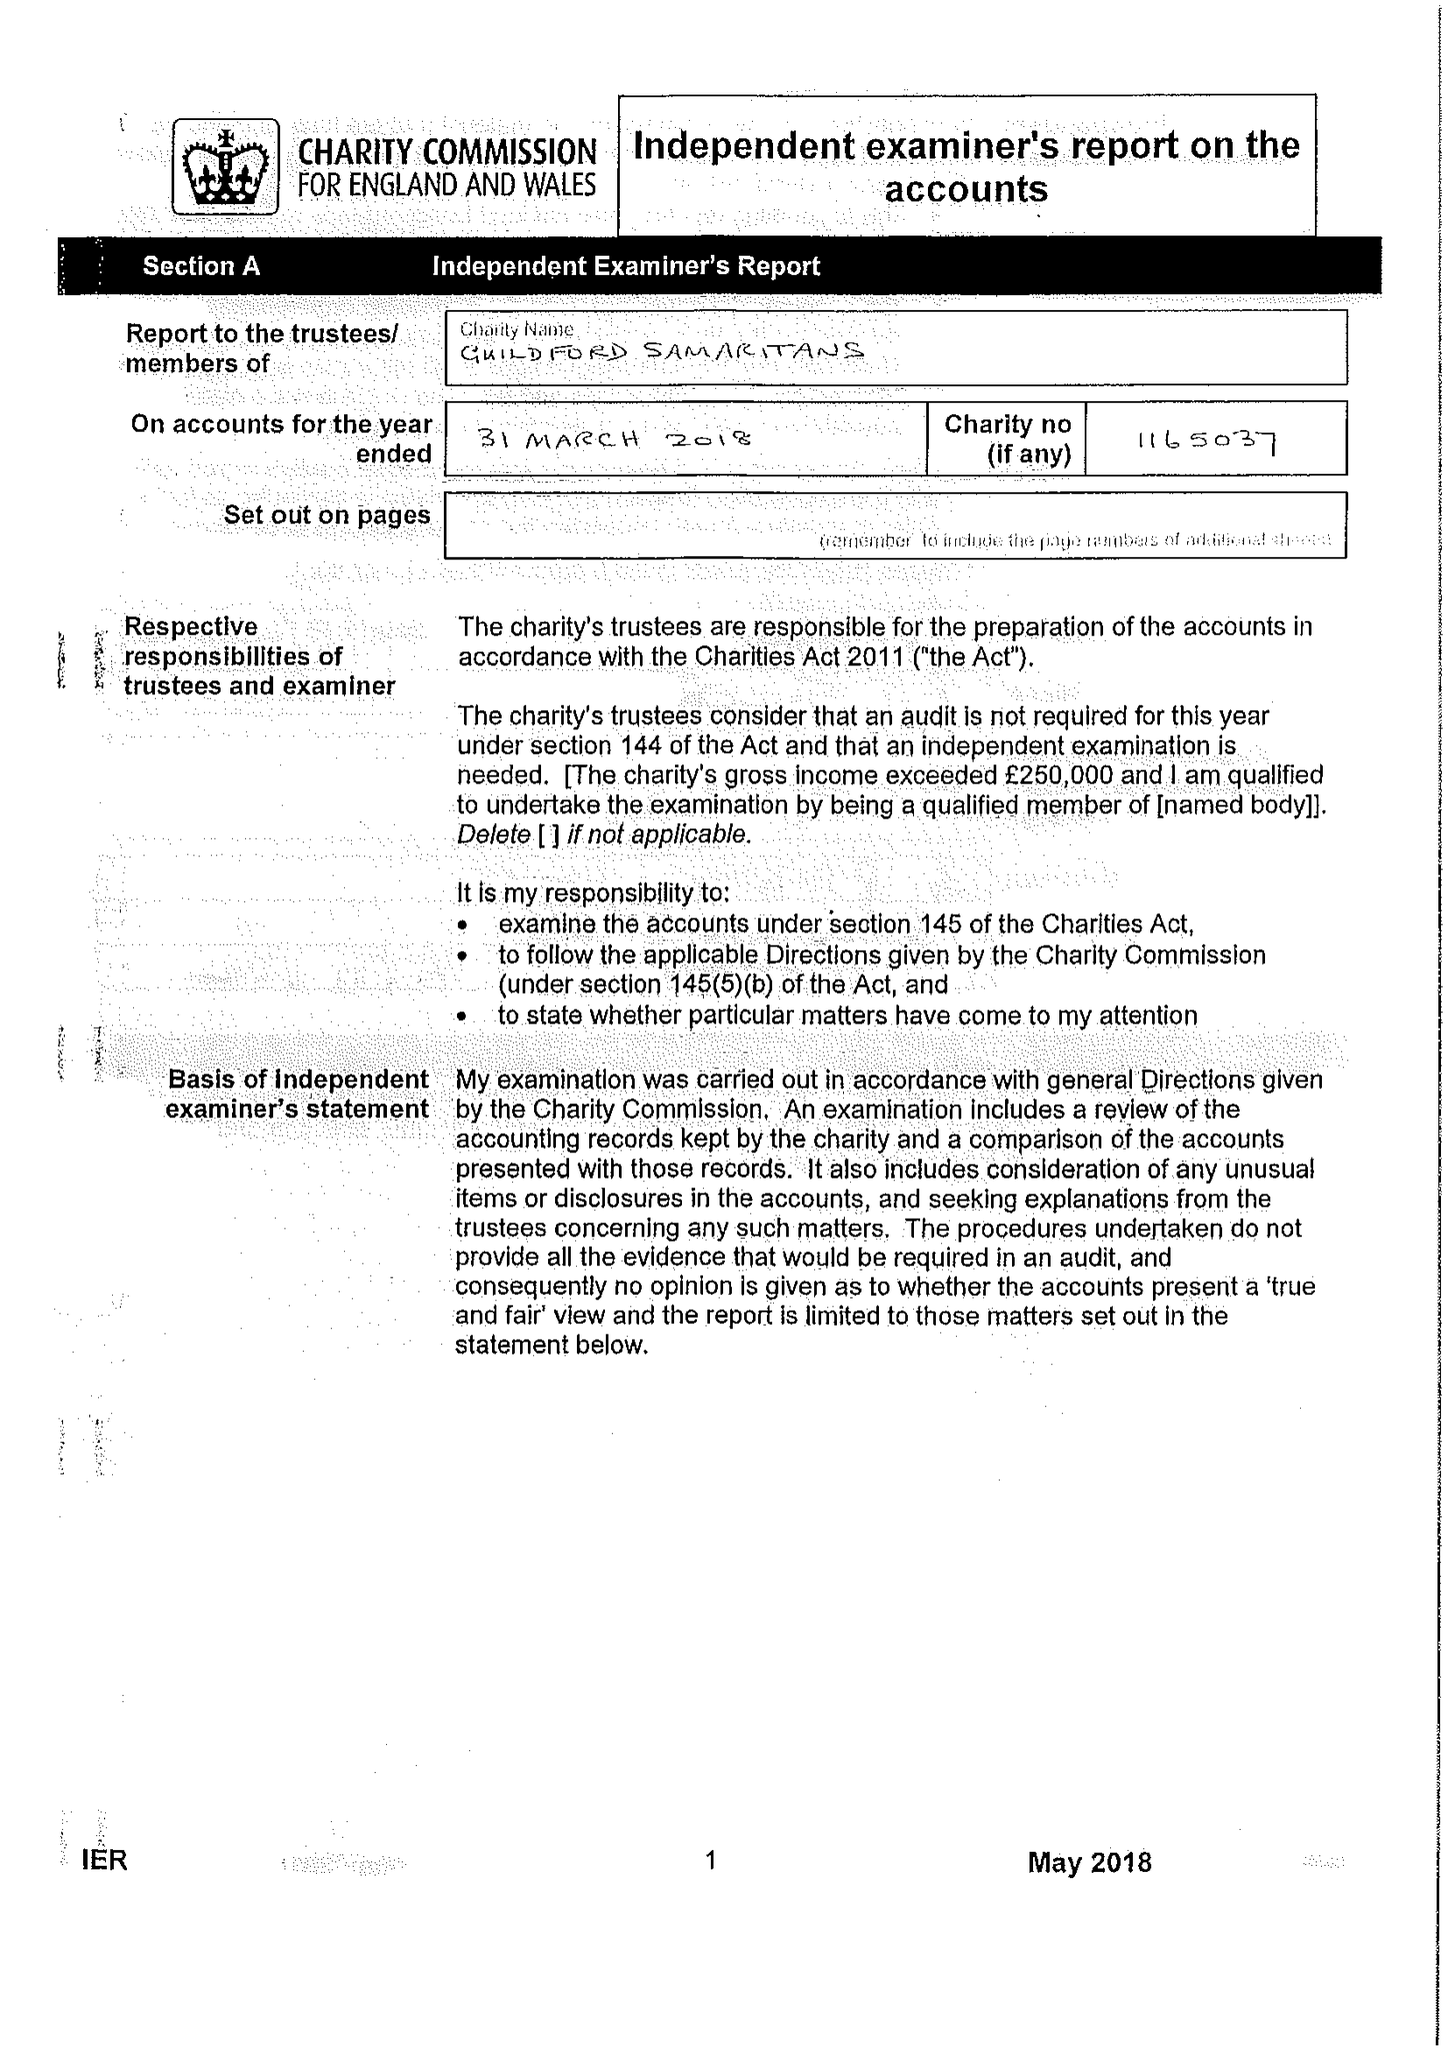What is the value for the address__postcode?
Answer the question using a single word or phrase. GU1 4RD 